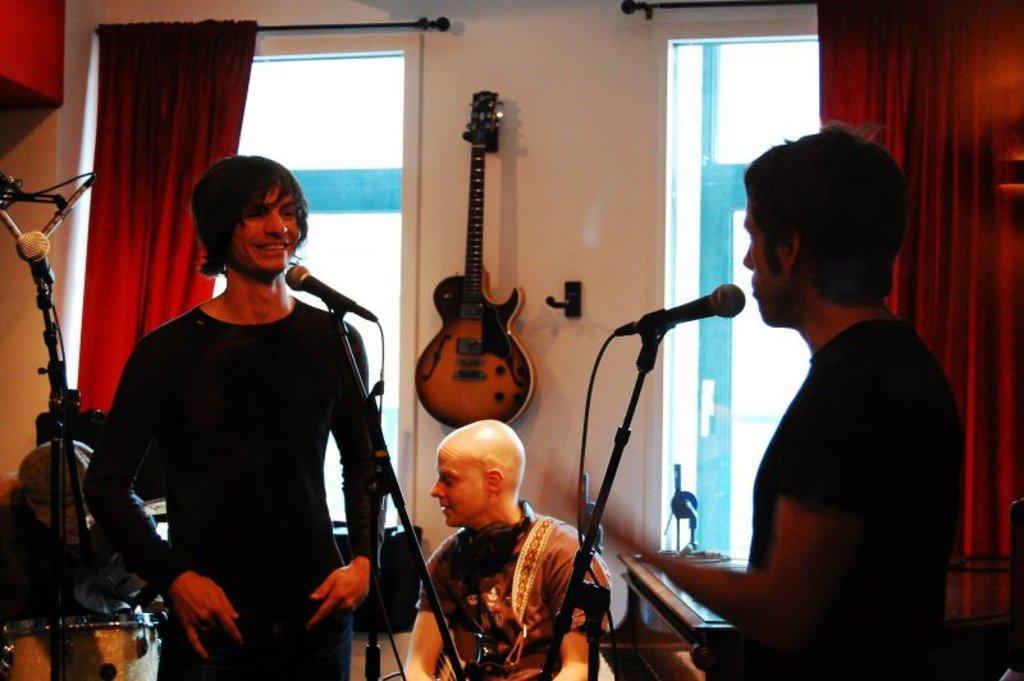Can you describe this image briefly? there are are two persons standing in front of a microphone one person is sitting there is a guitar hanging on the wall. 